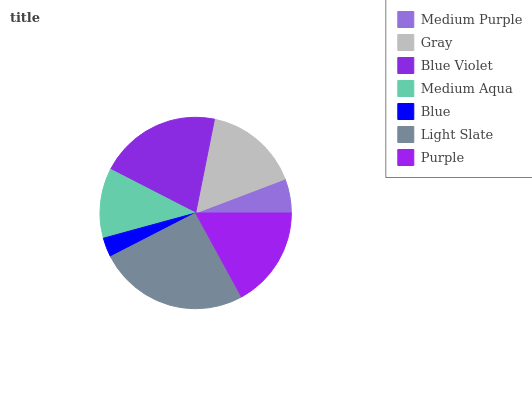Is Blue the minimum?
Answer yes or no. Yes. Is Light Slate the maximum?
Answer yes or no. Yes. Is Gray the minimum?
Answer yes or no. No. Is Gray the maximum?
Answer yes or no. No. Is Gray greater than Medium Purple?
Answer yes or no. Yes. Is Medium Purple less than Gray?
Answer yes or no. Yes. Is Medium Purple greater than Gray?
Answer yes or no. No. Is Gray less than Medium Purple?
Answer yes or no. No. Is Gray the high median?
Answer yes or no. Yes. Is Gray the low median?
Answer yes or no. Yes. Is Medium Purple the high median?
Answer yes or no. No. Is Blue Violet the low median?
Answer yes or no. No. 